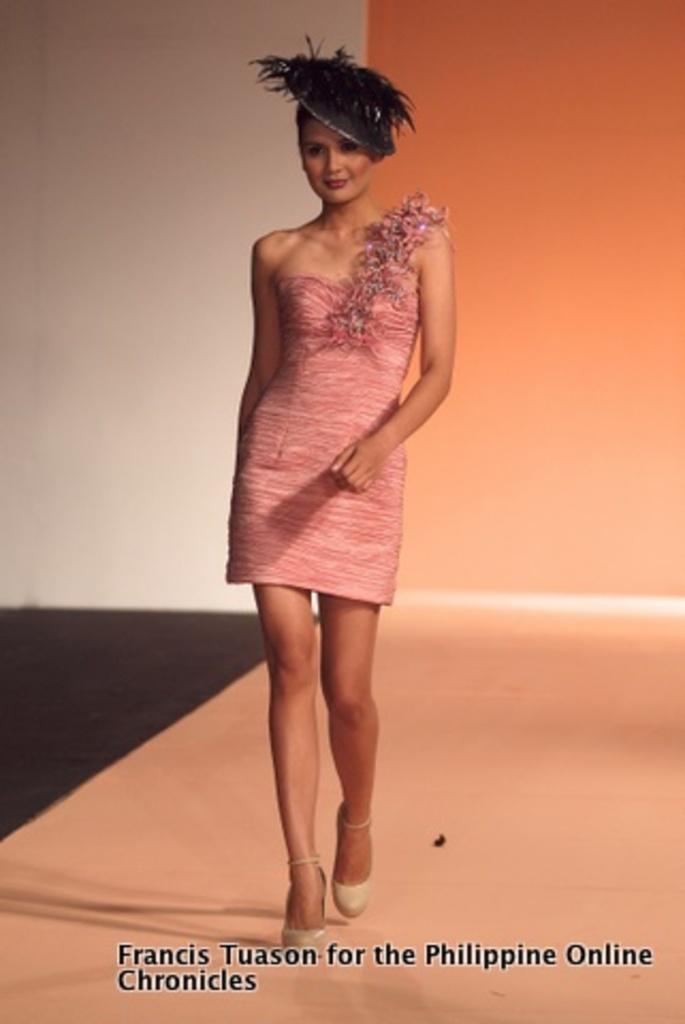Who is the main subject in the image? There is a lady in the image. What is the lady wearing on her head? The lady is wearing a hat. Where is the lady located in the image? The lady is walking on a stage. What type of cough does the writer have in the image? There is no writer or cough present in the image; it features a lady wearing a hat and walking on a stage. 